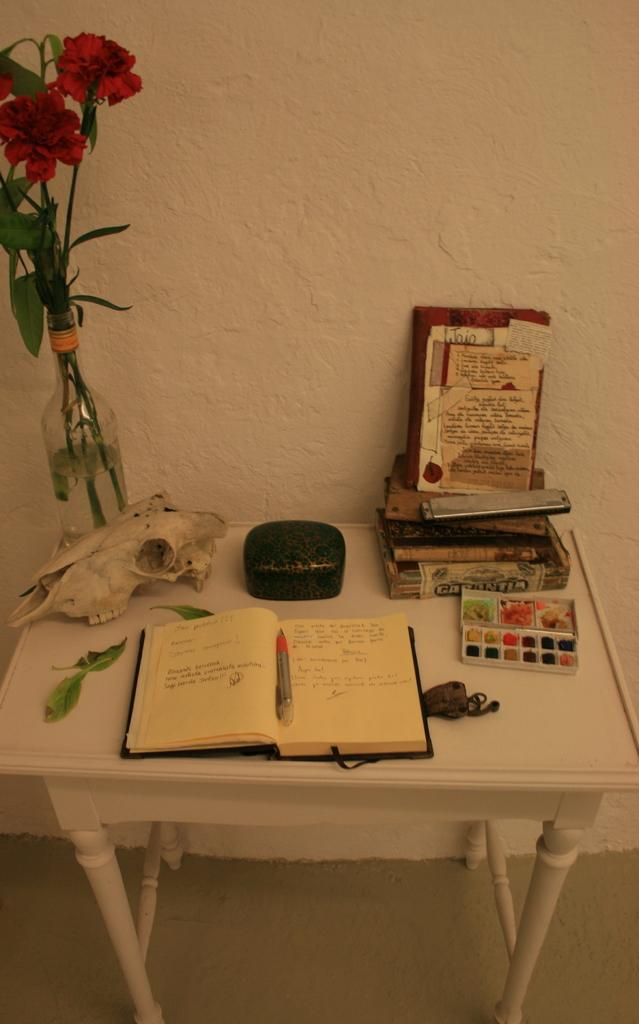What piece of furniture is present in the image? There is a table in the image. What items can be seen on the table? There is a book, a pen, a plant, and other unspecified things on the table. What is the background of the image? There is a wall visible in the image. Can you see a chain being used in a game of chess in the image? There is no chain or game of chess present in the image. What phase of the moon is visible in the image? The image does not show the moon, so it is not possible to determine the phase of the moon. 